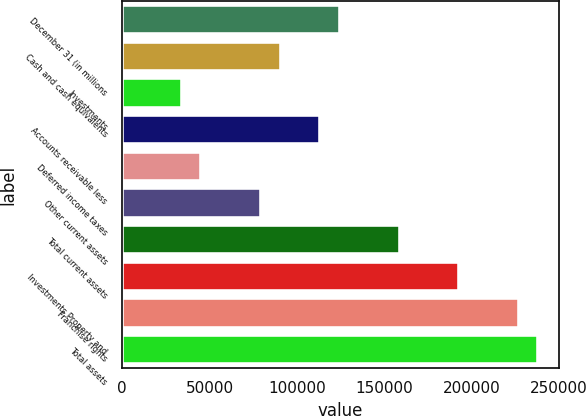Convert chart. <chart><loc_0><loc_0><loc_500><loc_500><bar_chart><fcel>December 31 (in millions<fcel>Cash and cash equivalents<fcel>Investments<fcel>Accounts receivable less<fcel>Deferred income taxes<fcel>Other current assets<fcel>Total current assets<fcel>Investments Property and<fcel>Franchise rights<fcel>Total assets<nl><fcel>124758<fcel>90735.6<fcel>34032.1<fcel>113417<fcel>45372.8<fcel>79394.9<fcel>158780<fcel>192802<fcel>226824<fcel>238165<nl></chart> 